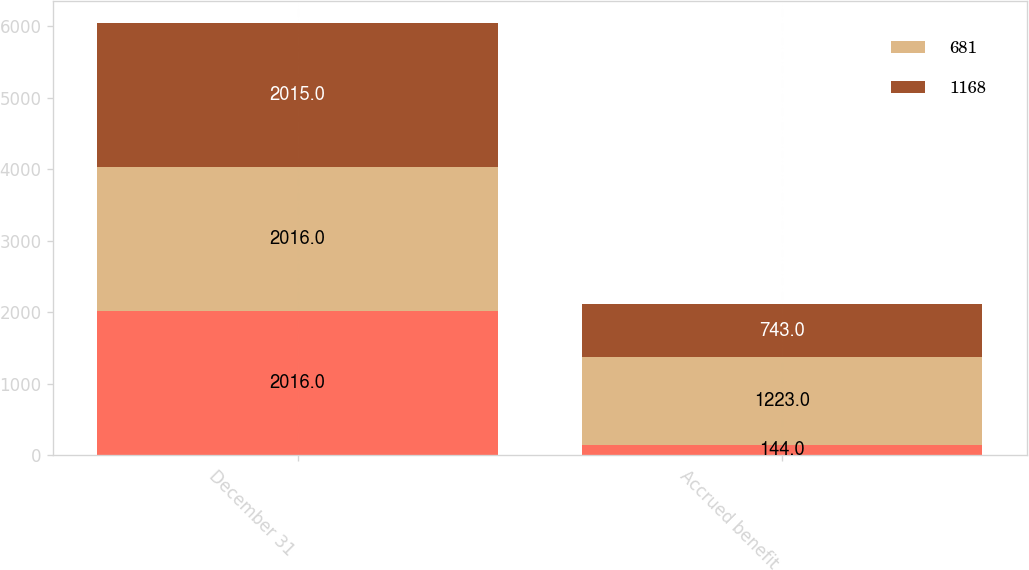Convert chart to OTSL. <chart><loc_0><loc_0><loc_500><loc_500><stacked_bar_chart><ecel><fcel>December 31<fcel>Accrued benefit<nl><fcel>nan<fcel>2016<fcel>144<nl><fcel>681<fcel>2016<fcel>1223<nl><fcel>1168<fcel>2015<fcel>743<nl></chart> 